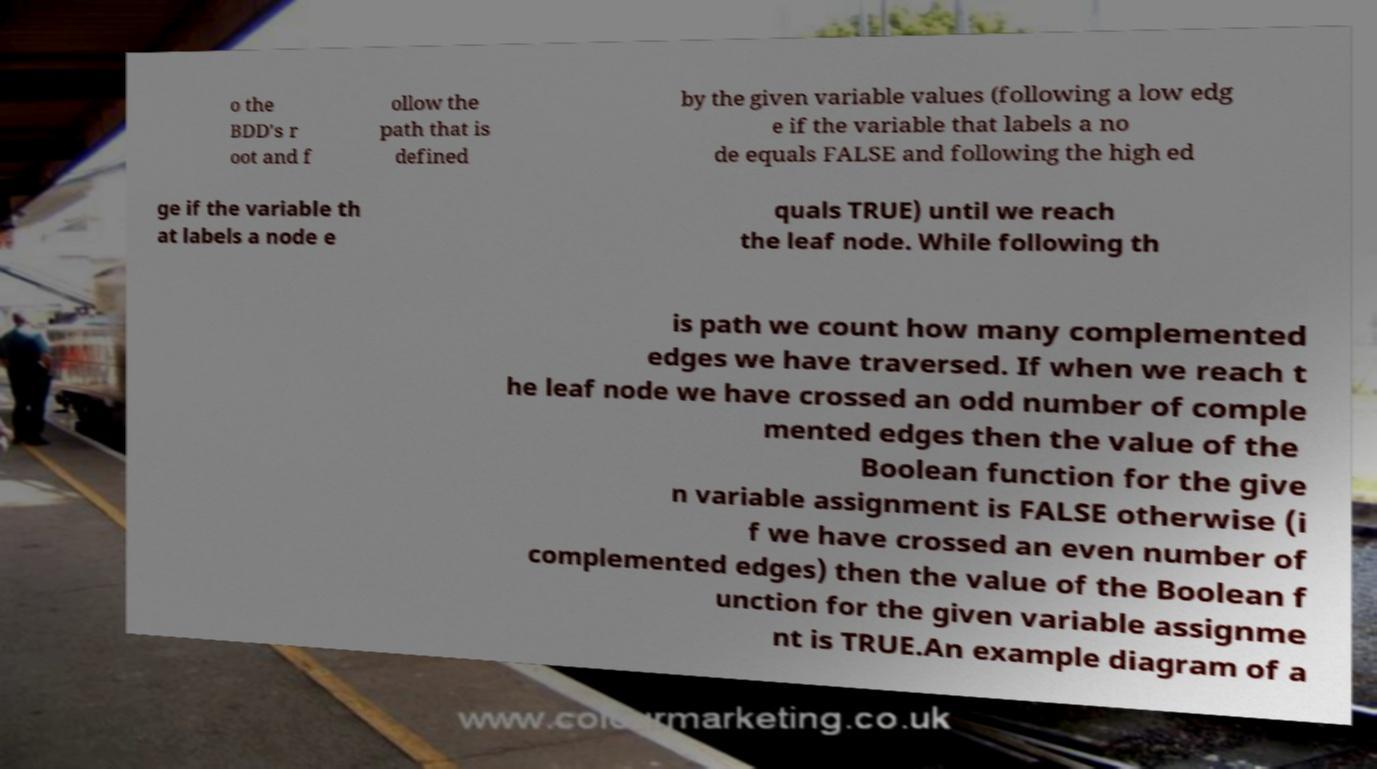What messages or text are displayed in this image? I need them in a readable, typed format. o the BDD's r oot and f ollow the path that is defined by the given variable values (following a low edg e if the variable that labels a no de equals FALSE and following the high ed ge if the variable th at labels a node e quals TRUE) until we reach the leaf node. While following th is path we count how many complemented edges we have traversed. If when we reach t he leaf node we have crossed an odd number of comple mented edges then the value of the Boolean function for the give n variable assignment is FALSE otherwise (i f we have crossed an even number of complemented edges) then the value of the Boolean f unction for the given variable assignme nt is TRUE.An example diagram of a 